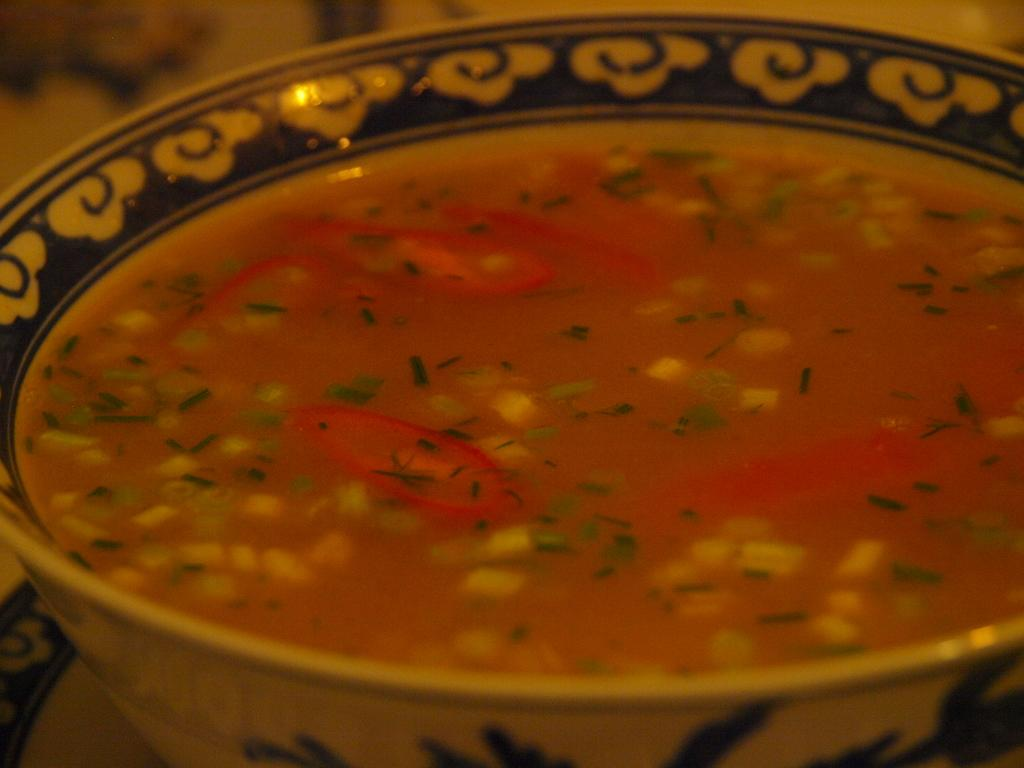What is in the bowl that is visible in the image? There is a bowl in the image. What is the contents of the bowl? The bowl contains soup. How many snails can be seen crawling on the edge of the bowl in the image? There are no snails present in the image; the bowl contains soup. What type of nut is used as a garnish on top of the soup in the image? There is no nut visible on top of the soup in the image. 